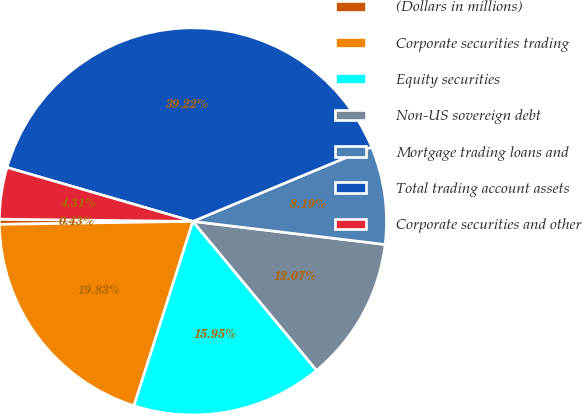Convert chart. <chart><loc_0><loc_0><loc_500><loc_500><pie_chart><fcel>(Dollars in millions)<fcel>Corporate securities trading<fcel>Equity securities<fcel>Non-US sovereign debt<fcel>Mortgage trading loans and<fcel>Total trading account assets<fcel>Corporate securities and other<nl><fcel>0.43%<fcel>19.83%<fcel>15.95%<fcel>12.07%<fcel>8.19%<fcel>39.22%<fcel>4.31%<nl></chart> 